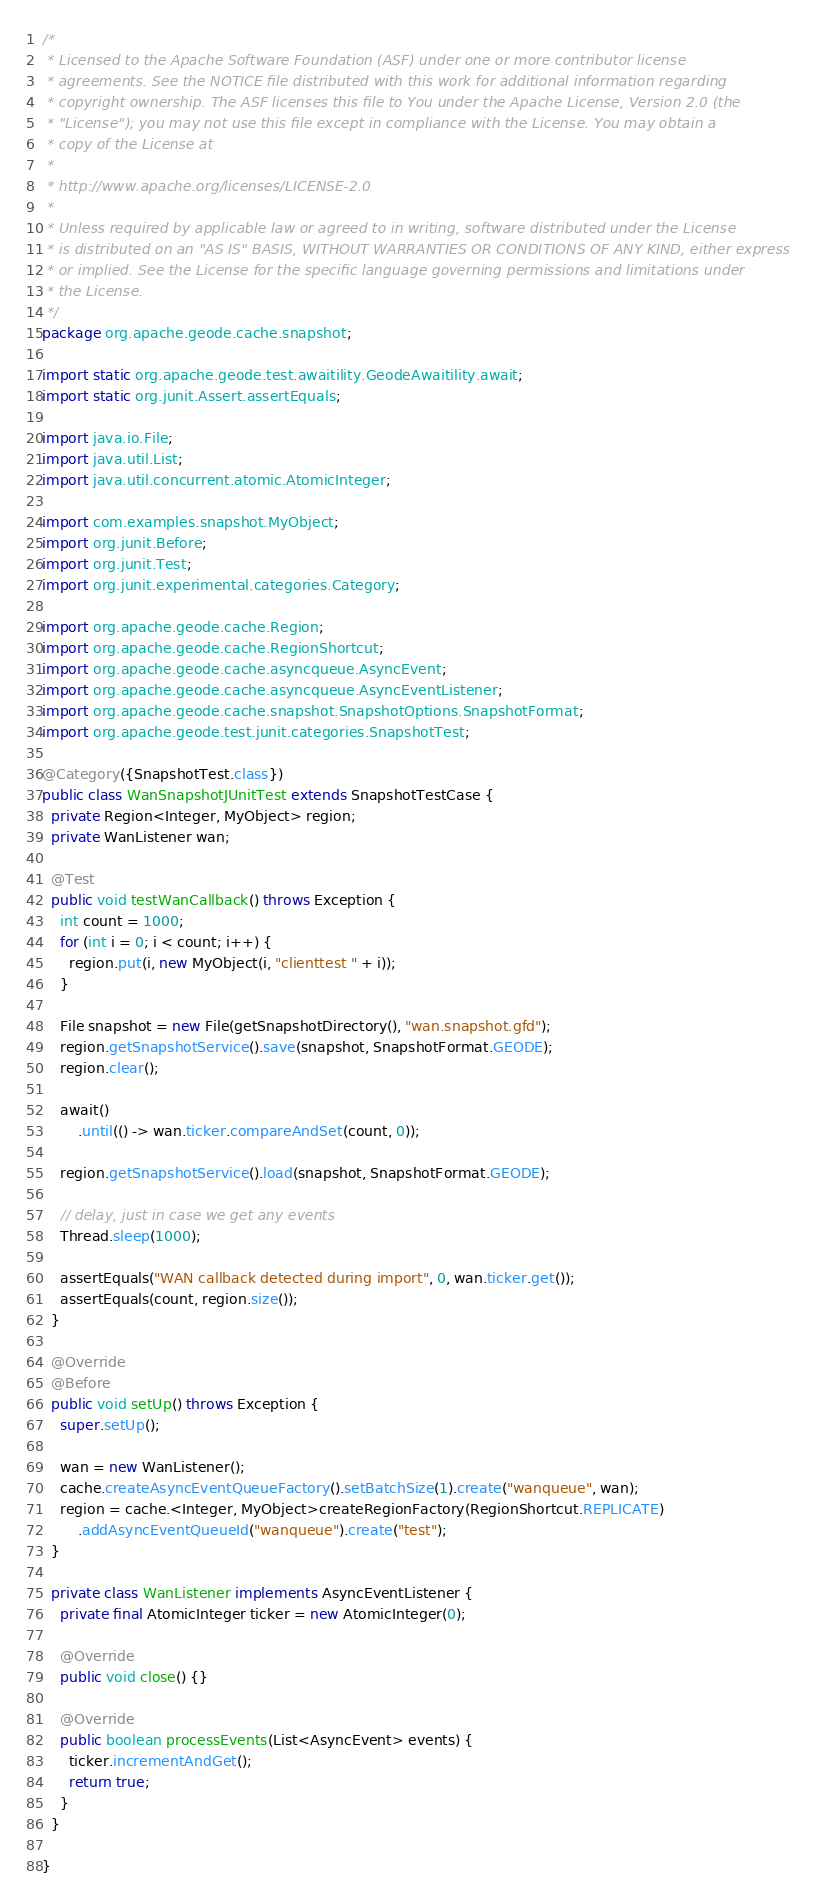Convert code to text. <code><loc_0><loc_0><loc_500><loc_500><_Java_>/*
 * Licensed to the Apache Software Foundation (ASF) under one or more contributor license
 * agreements. See the NOTICE file distributed with this work for additional information regarding
 * copyright ownership. The ASF licenses this file to You under the Apache License, Version 2.0 (the
 * "License"); you may not use this file except in compliance with the License. You may obtain a
 * copy of the License at
 *
 * http://www.apache.org/licenses/LICENSE-2.0
 *
 * Unless required by applicable law or agreed to in writing, software distributed under the License
 * is distributed on an "AS IS" BASIS, WITHOUT WARRANTIES OR CONDITIONS OF ANY KIND, either express
 * or implied. See the License for the specific language governing permissions and limitations under
 * the License.
 */
package org.apache.geode.cache.snapshot;

import static org.apache.geode.test.awaitility.GeodeAwaitility.await;
import static org.junit.Assert.assertEquals;

import java.io.File;
import java.util.List;
import java.util.concurrent.atomic.AtomicInteger;

import com.examples.snapshot.MyObject;
import org.junit.Before;
import org.junit.Test;
import org.junit.experimental.categories.Category;

import org.apache.geode.cache.Region;
import org.apache.geode.cache.RegionShortcut;
import org.apache.geode.cache.asyncqueue.AsyncEvent;
import org.apache.geode.cache.asyncqueue.AsyncEventListener;
import org.apache.geode.cache.snapshot.SnapshotOptions.SnapshotFormat;
import org.apache.geode.test.junit.categories.SnapshotTest;

@Category({SnapshotTest.class})
public class WanSnapshotJUnitTest extends SnapshotTestCase {
  private Region<Integer, MyObject> region;
  private WanListener wan;

  @Test
  public void testWanCallback() throws Exception {
    int count = 1000;
    for (int i = 0; i < count; i++) {
      region.put(i, new MyObject(i, "clienttest " + i));
    }

    File snapshot = new File(getSnapshotDirectory(), "wan.snapshot.gfd");
    region.getSnapshotService().save(snapshot, SnapshotFormat.GEODE);
    region.clear();

    await()
        .until(() -> wan.ticker.compareAndSet(count, 0));

    region.getSnapshotService().load(snapshot, SnapshotFormat.GEODE);

    // delay, just in case we get any events
    Thread.sleep(1000);

    assertEquals("WAN callback detected during import", 0, wan.ticker.get());
    assertEquals(count, region.size());
  }

  @Override
  @Before
  public void setUp() throws Exception {
    super.setUp();

    wan = new WanListener();
    cache.createAsyncEventQueueFactory().setBatchSize(1).create("wanqueue", wan);
    region = cache.<Integer, MyObject>createRegionFactory(RegionShortcut.REPLICATE)
        .addAsyncEventQueueId("wanqueue").create("test");
  }

  private class WanListener implements AsyncEventListener {
    private final AtomicInteger ticker = new AtomicInteger(0);

    @Override
    public void close() {}

    @Override
    public boolean processEvents(List<AsyncEvent> events) {
      ticker.incrementAndGet();
      return true;
    }
  }

}
</code> 